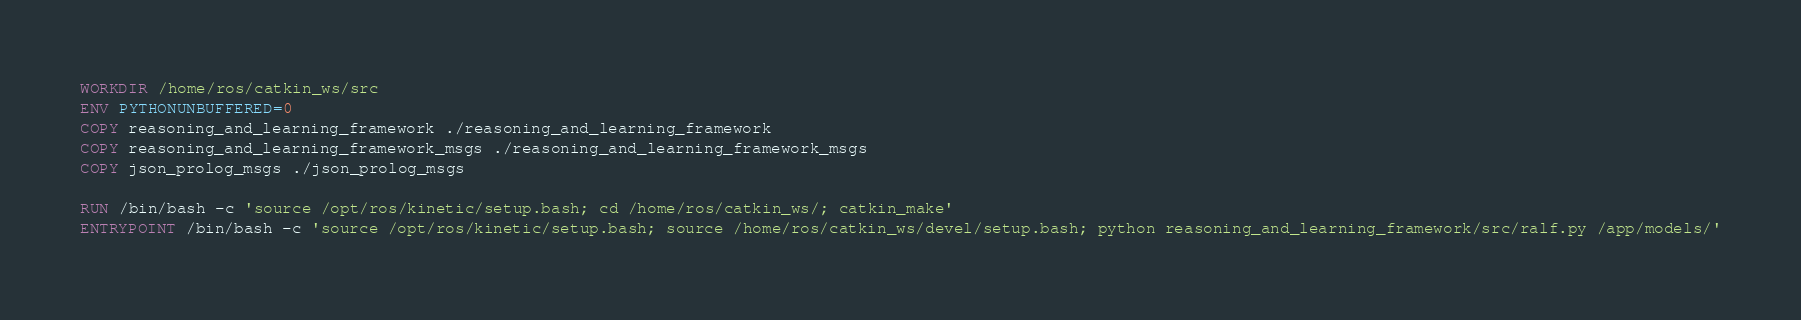<code> <loc_0><loc_0><loc_500><loc_500><_Dockerfile_>WORKDIR /home/ros/catkin_ws/src
ENV PYTHONUNBUFFERED=0
COPY reasoning_and_learning_framework ./reasoning_and_learning_framework
COPY reasoning_and_learning_framework_msgs ./reasoning_and_learning_framework_msgs
COPY json_prolog_msgs ./json_prolog_msgs

RUN /bin/bash -c 'source /opt/ros/kinetic/setup.bash; cd /home/ros/catkin_ws/; catkin_make'
ENTRYPOINT /bin/bash -c 'source /opt/ros/kinetic/setup.bash; source /home/ros/catkin_ws/devel/setup.bash; python reasoning_and_learning_framework/src/ralf.py /app/models/'
</code> 